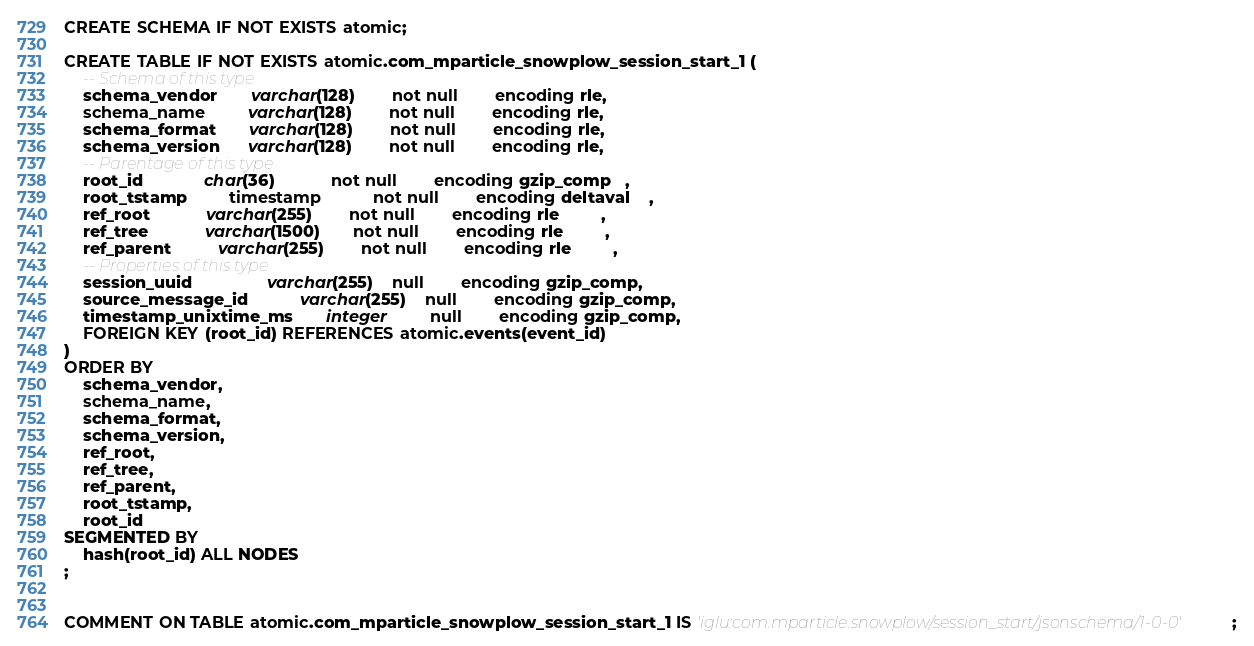Convert code to text. <code><loc_0><loc_0><loc_500><loc_500><_SQL_>CREATE SCHEMA IF NOT EXISTS atomic;

CREATE TABLE IF NOT EXISTS atomic.com_mparticle_snowplow_session_start_1 (
    -- Schema of this type
    schema_vendor       varchar(128)        not null        encoding rle,
    schema_name         varchar(128)        not null        encoding rle,
    schema_format       varchar(128)        not null        encoding rle,
    schema_version      varchar(128)        not null        encoding rle,
    -- Parentage of this type
    root_id             char(36)            not null        encoding gzip_comp   ,
    root_tstamp         timestamp           not null        encoding deltaval    ,
    ref_root            varchar(255)        not null        encoding rle         ,
    ref_tree            varchar(1500)       not null        encoding rle         ,
    ref_parent          varchar(255)        not null        encoding rle         ,
    -- Properties of this type
    session_uuid                varchar(255)    null        encoding gzip_comp,
    source_message_id           varchar(255)    null        encoding gzip_comp,
    timestamp_unixtime_ms       integer         null        encoding gzip_comp,
    FOREIGN KEY (root_id) REFERENCES atomic.events(event_id)
)
ORDER BY
    schema_vendor,
    schema_name,
    schema_format,
    schema_version,
    ref_root,
    ref_tree,
    ref_parent,
    root_tstamp,
    root_id
SEGMENTED BY
    hash(root_id) ALL NODES
;


COMMENT ON TABLE atomic.com_mparticle_snowplow_session_start_1 IS 'iglu:com.mparticle.snowplow/session_start/jsonschema/1-0-0';
</code> 